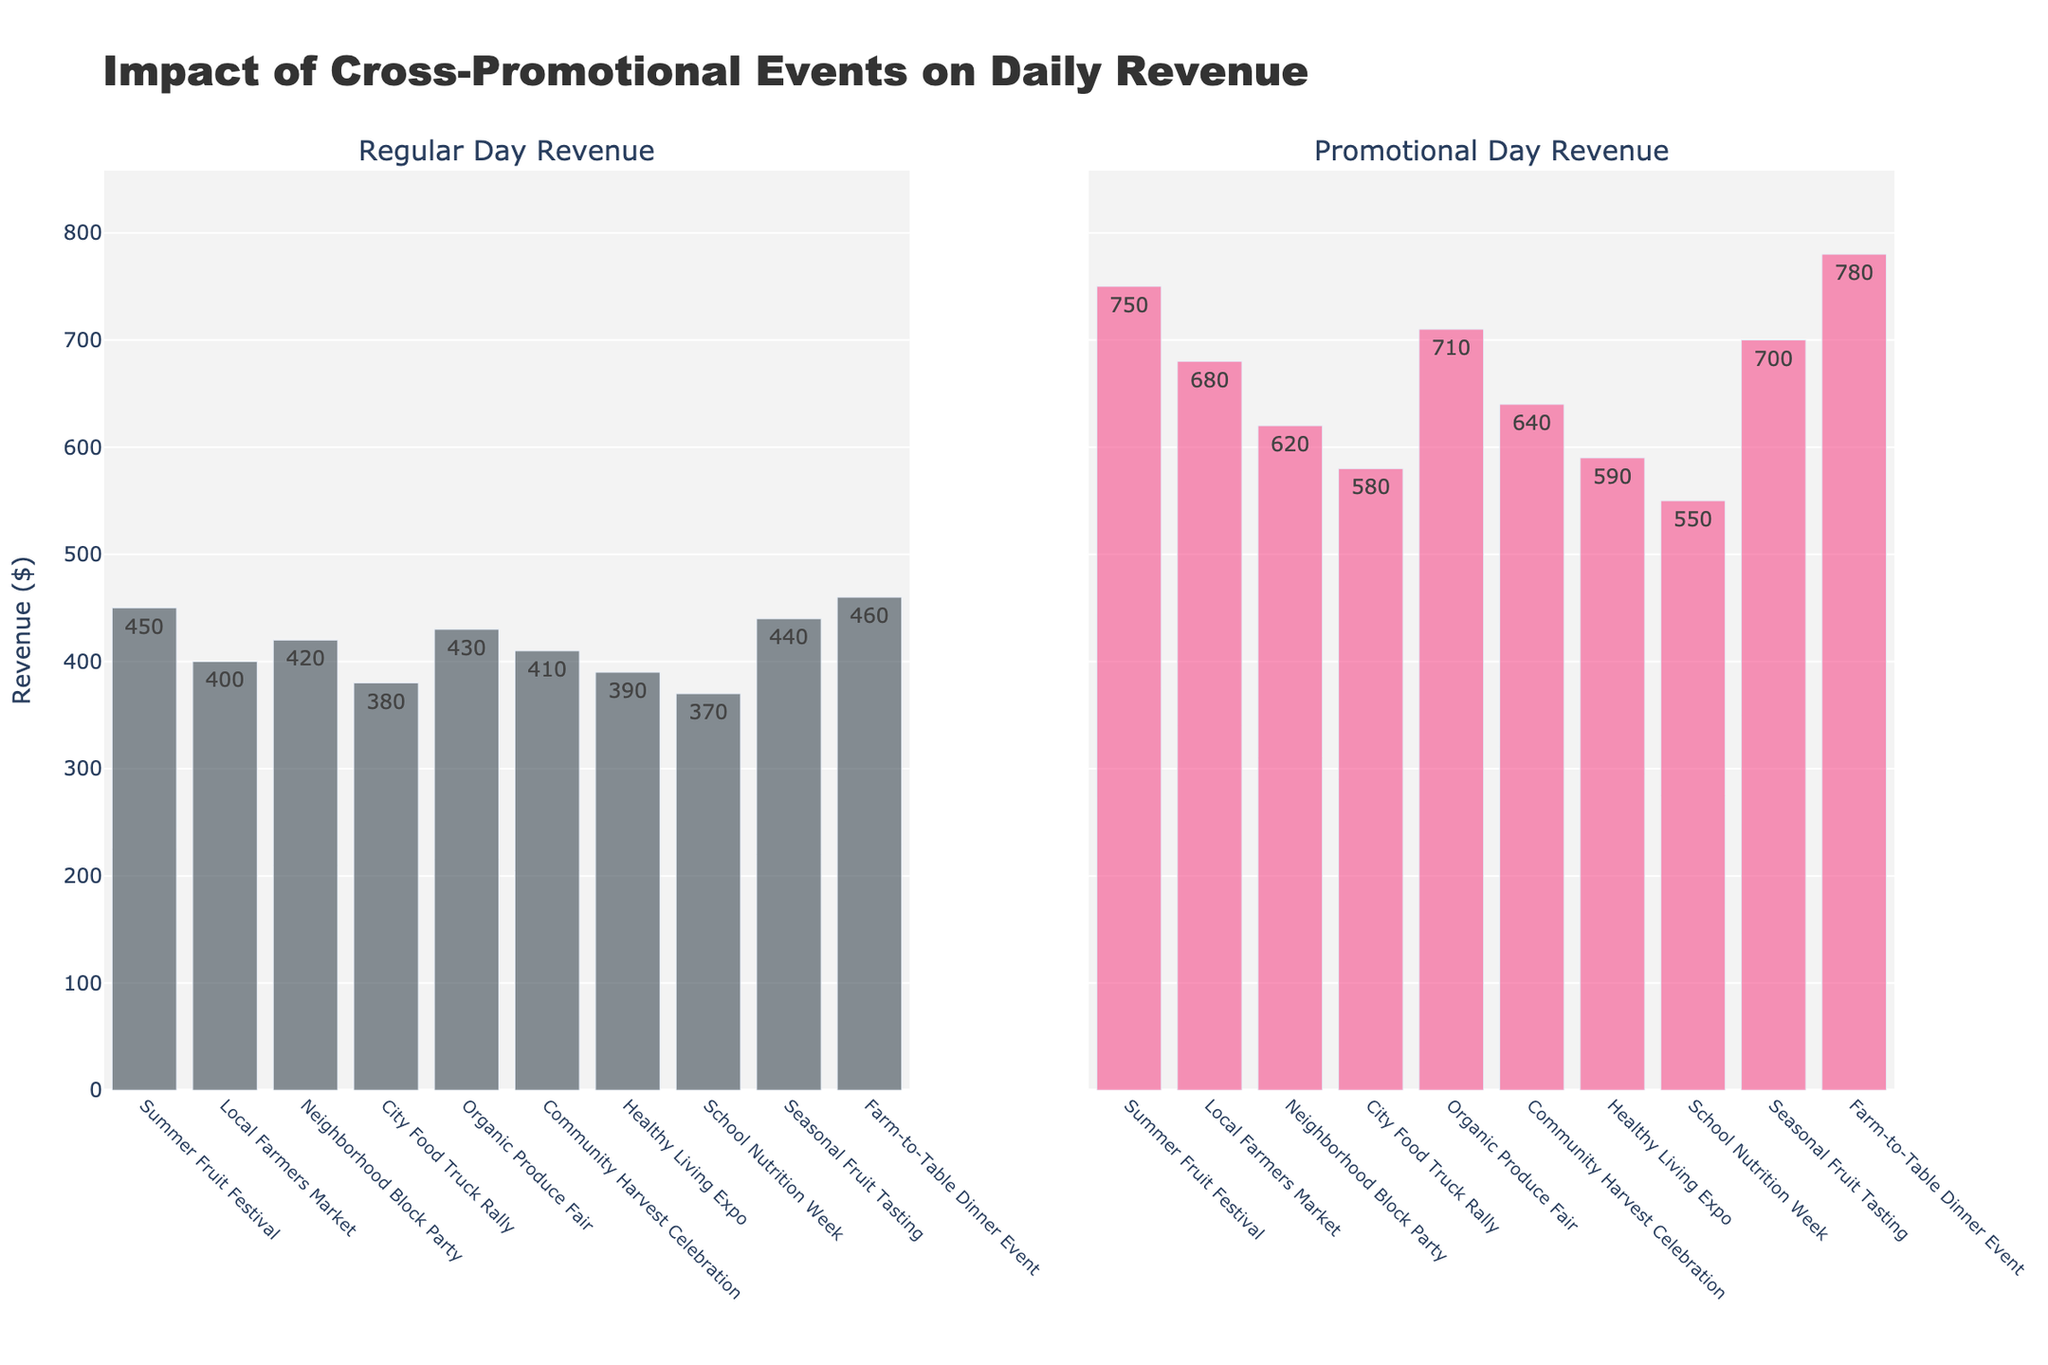How many events are displayed in the figure? Count the number of bars shown in either subplot, as each bar corresponds to one event. There are 10 events in total.
Answer: 10 What is the highest promotional day revenue shown in the figure? Look at the bar heights for Promotional Day Revenue and find the highest value. The highest value is $780 from the Farm-to-Table Dinner Event.
Answer: $780 Which event has the lowest regular day revenue? Compare the bar heights for Regular Day Revenue and identify the smallest value. The event with the lowest regular day revenue is the School Nutrition Week with $370.
Answer: School Nutrition Week What is the difference between the highest and lowest promotional day revenue? Identify the highest and lowest promotional day revenue values and subtract the lowest from the highest. The highest is $780 (Farm-to-Table Dinner Event) and the lowest is $550 (School Nutrition Week), thus the difference is $780 - $550 = $230.
Answer: $230 On average, how much more revenue is made on promotional days compared to regular days? For each event, calculate the difference between Promotional Day Revenue and Regular Day Revenue, sum up these differences, and then divide by the number of events. Differences: 300, 280, 200, 200, 280, 230, 200, 180, 260, 320. Sum = 2450. Average difference = 2450/10 = 245.
Answer: $245 Which event has the smallest increase in revenue from regular to promotional day? Calculate the differences for each event by subtracting Regular Day Revenue from Promotional Day Revenue, and identify the event with the smallest difference. The smallest increase is $180 for the School Nutrition Week.
Answer: School Nutrition Week For which event does the regular day revenue make up the highest percentage of the promotional day revenue? For each event, compute (Regular Day Revenue / Promotional Day Revenue) * 100, and find the highest percentage. The highest percentage is for the School Nutrition Week (($370 / $550) * 100) ≈ 67.27%.
Answer: School Nutrition Week Do any events have the same revenue difference between regular and promotional days? If so, which ones? Calculate the revenue differences for all events and find any equal differences. "Local Farmers Market" and "Organic Produce Fair" both have a difference of $280.
Answer: Local Farmers Market, Organic Produce Fair How much more revenue does the Farm-to-Table Dinner Event make on a promotional day compared to the City Food Truck Rally on a promotional day? Subtract the promotional day revenue of the City Food Truck Rally from that of the Farm-to-Table Dinner Event. The difference is $780 - $580 = $200.
Answer: $200 